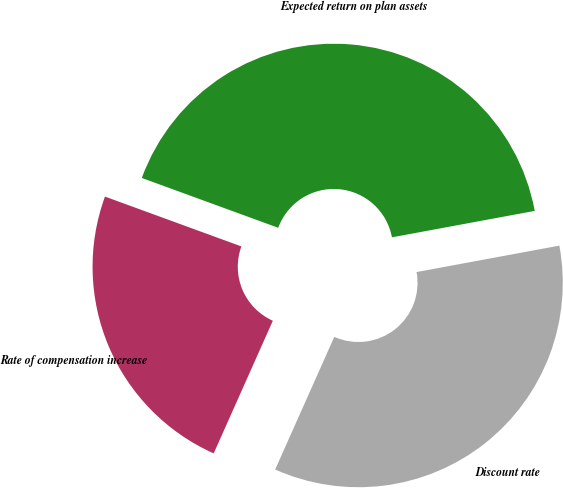Convert chart. <chart><loc_0><loc_0><loc_500><loc_500><pie_chart><fcel>Discount rate<fcel>Expected return on plan assets<fcel>Rate of compensation increase<nl><fcel>34.59%<fcel>41.51%<fcel>23.9%<nl></chart> 